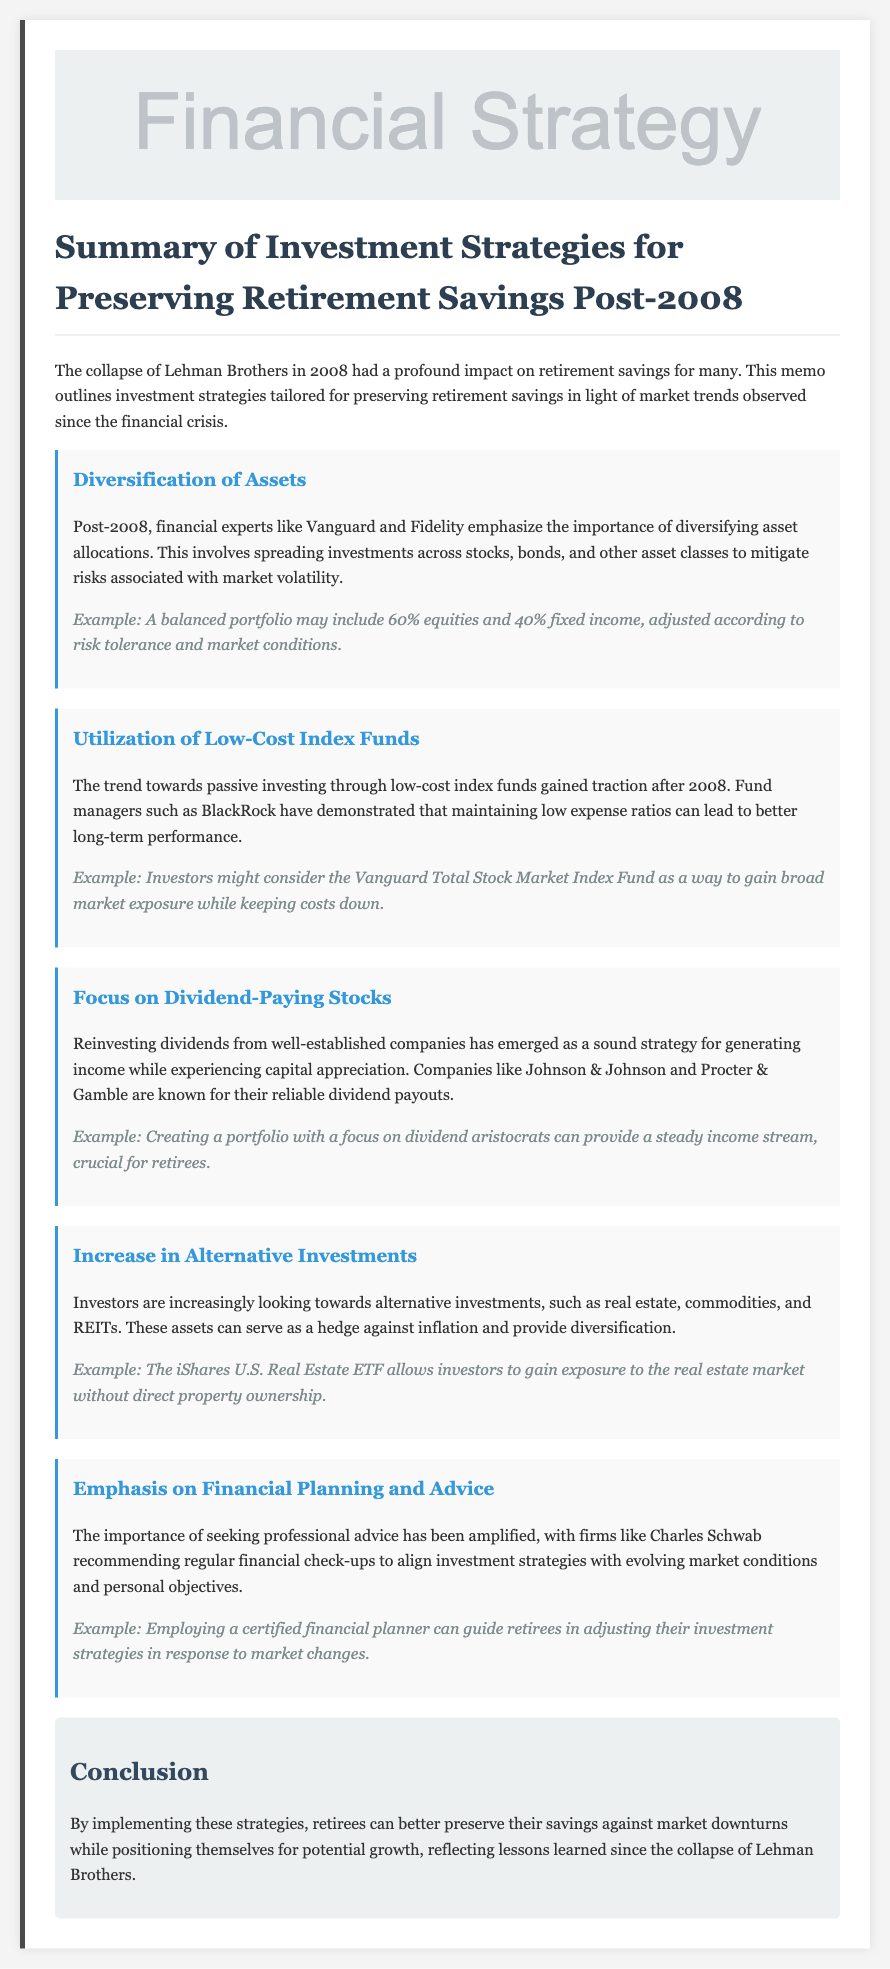What is the title of the memo? The title is the main heading of the memo that gives a summary of its content.
Answer: Summary of Investment Strategies for Preserving Retirement Savings Post-2008 What company collapsed in 2008? The document refers to a specific company that had significant financial implications.
Answer: Lehman Brothers What investment strategy emphasizes the importance of spreading investments? This strategy involves distributing assets to reduce risk associated with market fluctuations.
Answer: Diversification of Assets Which type of funds gained traction post-2008 for their low expense ratios? The memo highlights a particular kind of investment fund known for low costs.
Answer: Low-Cost Index Funds Name a company known for reliable dividend payouts. This information aligns with the focus on stocks that provide steady income for retirees.
Answer: Johnson & Johnson What alternative investment is mentioned in the memo? The document points out a specific type of asset class considered as an alternative investment.
Answer: Real estate How much percentage allocation is suggested for equities in a balanced portfolio? This percentage is specified as a recommendation for balancing risk and returns.
Answer: 60% What is one recommended action for retirees according to financial experts? This advice relates to staying updated on personal finance and investments.
Answer: Regular financial check-ups Which ETF allows exposure to the real estate market? The document provides the name of an investment fund that provides access to the real estate sector.
Answer: iShares U.S. Real Estate ETF 